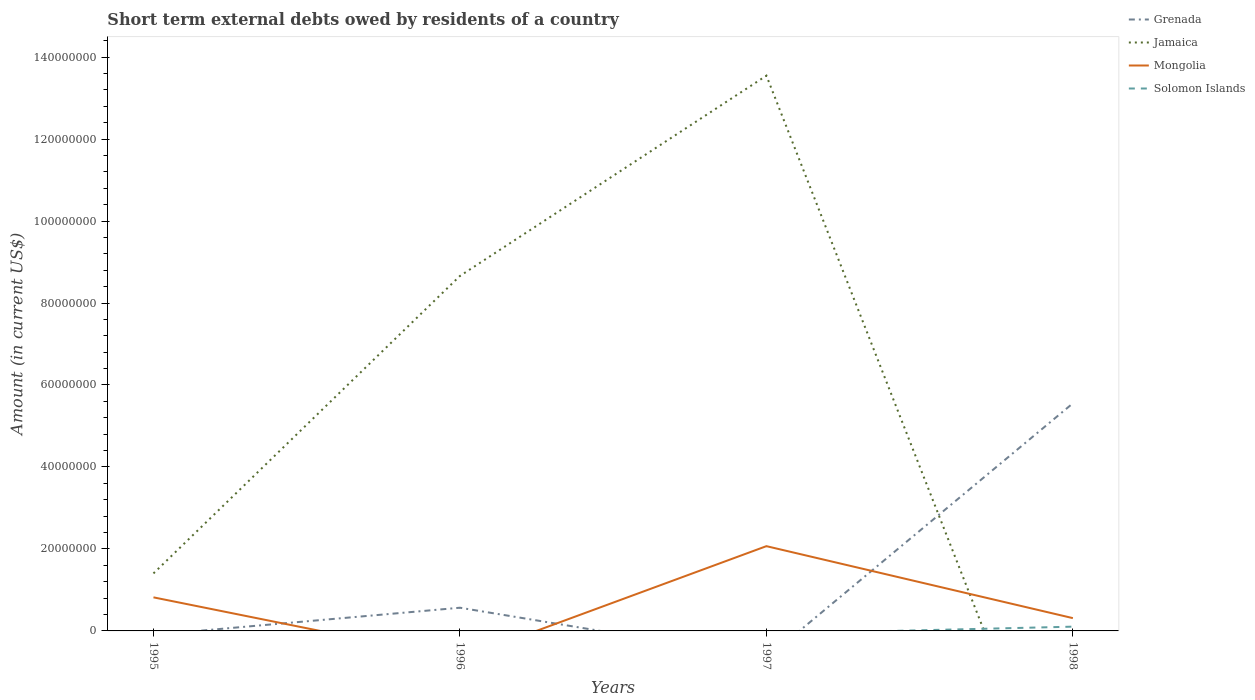Across all years, what is the maximum amount of short-term external debts owed by residents in Grenada?
Offer a very short reply. 0. What is the total amount of short-term external debts owed by residents in Mongolia in the graph?
Offer a terse response. 5.07e+06. What is the difference between the highest and the second highest amount of short-term external debts owed by residents in Grenada?
Your response must be concise. 5.55e+07. What is the difference between the highest and the lowest amount of short-term external debts owed by residents in Mongolia?
Make the answer very short. 2. Does the graph contain grids?
Provide a succinct answer. No. How many legend labels are there?
Keep it short and to the point. 4. What is the title of the graph?
Offer a terse response. Short term external debts owed by residents of a country. Does "Syrian Arab Republic" appear as one of the legend labels in the graph?
Offer a terse response. No. What is the label or title of the Y-axis?
Your answer should be compact. Amount (in current US$). What is the Amount (in current US$) in Jamaica in 1995?
Provide a succinct answer. 1.40e+07. What is the Amount (in current US$) in Mongolia in 1995?
Provide a short and direct response. 8.19e+06. What is the Amount (in current US$) of Grenada in 1996?
Your answer should be compact. 5.66e+06. What is the Amount (in current US$) in Jamaica in 1996?
Provide a succinct answer. 8.66e+07. What is the Amount (in current US$) of Mongolia in 1996?
Your answer should be very brief. 0. What is the Amount (in current US$) of Solomon Islands in 1996?
Give a very brief answer. 0. What is the Amount (in current US$) in Jamaica in 1997?
Give a very brief answer. 1.35e+08. What is the Amount (in current US$) in Mongolia in 1997?
Make the answer very short. 2.07e+07. What is the Amount (in current US$) of Grenada in 1998?
Keep it short and to the point. 5.55e+07. What is the Amount (in current US$) of Mongolia in 1998?
Make the answer very short. 3.12e+06. What is the Amount (in current US$) in Solomon Islands in 1998?
Your response must be concise. 1.04e+06. Across all years, what is the maximum Amount (in current US$) in Grenada?
Offer a terse response. 5.55e+07. Across all years, what is the maximum Amount (in current US$) in Jamaica?
Provide a succinct answer. 1.35e+08. Across all years, what is the maximum Amount (in current US$) of Mongolia?
Provide a succinct answer. 2.07e+07. Across all years, what is the maximum Amount (in current US$) in Solomon Islands?
Offer a terse response. 1.04e+06. Across all years, what is the minimum Amount (in current US$) of Grenada?
Your response must be concise. 0. Across all years, what is the minimum Amount (in current US$) of Jamaica?
Offer a very short reply. 0. What is the total Amount (in current US$) in Grenada in the graph?
Offer a terse response. 6.12e+07. What is the total Amount (in current US$) of Jamaica in the graph?
Provide a short and direct response. 2.36e+08. What is the total Amount (in current US$) of Mongolia in the graph?
Your response must be concise. 3.20e+07. What is the total Amount (in current US$) in Solomon Islands in the graph?
Your response must be concise. 1.04e+06. What is the difference between the Amount (in current US$) of Jamaica in 1995 and that in 1996?
Keep it short and to the point. -7.26e+07. What is the difference between the Amount (in current US$) of Jamaica in 1995 and that in 1997?
Offer a terse response. -1.21e+08. What is the difference between the Amount (in current US$) of Mongolia in 1995 and that in 1997?
Keep it short and to the point. -1.25e+07. What is the difference between the Amount (in current US$) in Mongolia in 1995 and that in 1998?
Offer a terse response. 5.07e+06. What is the difference between the Amount (in current US$) in Jamaica in 1996 and that in 1997?
Offer a very short reply. -4.89e+07. What is the difference between the Amount (in current US$) in Grenada in 1996 and that in 1998?
Make the answer very short. -4.99e+07. What is the difference between the Amount (in current US$) of Mongolia in 1997 and that in 1998?
Offer a terse response. 1.76e+07. What is the difference between the Amount (in current US$) of Jamaica in 1995 and the Amount (in current US$) of Mongolia in 1997?
Keep it short and to the point. -6.65e+06. What is the difference between the Amount (in current US$) in Jamaica in 1995 and the Amount (in current US$) in Mongolia in 1998?
Provide a succinct answer. 1.09e+07. What is the difference between the Amount (in current US$) of Jamaica in 1995 and the Amount (in current US$) of Solomon Islands in 1998?
Offer a very short reply. 1.30e+07. What is the difference between the Amount (in current US$) of Mongolia in 1995 and the Amount (in current US$) of Solomon Islands in 1998?
Make the answer very short. 7.15e+06. What is the difference between the Amount (in current US$) in Grenada in 1996 and the Amount (in current US$) in Jamaica in 1997?
Your response must be concise. -1.30e+08. What is the difference between the Amount (in current US$) in Grenada in 1996 and the Amount (in current US$) in Mongolia in 1997?
Provide a short and direct response. -1.50e+07. What is the difference between the Amount (in current US$) in Jamaica in 1996 and the Amount (in current US$) in Mongolia in 1997?
Keep it short and to the point. 6.59e+07. What is the difference between the Amount (in current US$) in Grenada in 1996 and the Amount (in current US$) in Mongolia in 1998?
Your response must be concise. 2.54e+06. What is the difference between the Amount (in current US$) in Grenada in 1996 and the Amount (in current US$) in Solomon Islands in 1998?
Keep it short and to the point. 4.62e+06. What is the difference between the Amount (in current US$) in Jamaica in 1996 and the Amount (in current US$) in Mongolia in 1998?
Your response must be concise. 8.35e+07. What is the difference between the Amount (in current US$) of Jamaica in 1996 and the Amount (in current US$) of Solomon Islands in 1998?
Provide a short and direct response. 8.56e+07. What is the difference between the Amount (in current US$) in Jamaica in 1997 and the Amount (in current US$) in Mongolia in 1998?
Your response must be concise. 1.32e+08. What is the difference between the Amount (in current US$) of Jamaica in 1997 and the Amount (in current US$) of Solomon Islands in 1998?
Your answer should be very brief. 1.34e+08. What is the difference between the Amount (in current US$) in Mongolia in 1997 and the Amount (in current US$) in Solomon Islands in 1998?
Provide a short and direct response. 1.96e+07. What is the average Amount (in current US$) in Grenada per year?
Give a very brief answer. 1.53e+07. What is the average Amount (in current US$) in Jamaica per year?
Keep it short and to the point. 5.90e+07. What is the average Amount (in current US$) of Mongolia per year?
Offer a very short reply. 8.00e+06. In the year 1995, what is the difference between the Amount (in current US$) of Jamaica and Amount (in current US$) of Mongolia?
Provide a short and direct response. 5.84e+06. In the year 1996, what is the difference between the Amount (in current US$) in Grenada and Amount (in current US$) in Jamaica?
Make the answer very short. -8.09e+07. In the year 1997, what is the difference between the Amount (in current US$) in Jamaica and Amount (in current US$) in Mongolia?
Offer a very short reply. 1.15e+08. In the year 1998, what is the difference between the Amount (in current US$) in Grenada and Amount (in current US$) in Mongolia?
Your answer should be very brief. 5.24e+07. In the year 1998, what is the difference between the Amount (in current US$) of Grenada and Amount (in current US$) of Solomon Islands?
Your response must be concise. 5.45e+07. In the year 1998, what is the difference between the Amount (in current US$) of Mongolia and Amount (in current US$) of Solomon Islands?
Keep it short and to the point. 2.08e+06. What is the ratio of the Amount (in current US$) in Jamaica in 1995 to that in 1996?
Make the answer very short. 0.16. What is the ratio of the Amount (in current US$) in Jamaica in 1995 to that in 1997?
Give a very brief answer. 0.1. What is the ratio of the Amount (in current US$) of Mongolia in 1995 to that in 1997?
Your response must be concise. 0.4. What is the ratio of the Amount (in current US$) in Mongolia in 1995 to that in 1998?
Your answer should be very brief. 2.62. What is the ratio of the Amount (in current US$) in Jamaica in 1996 to that in 1997?
Make the answer very short. 0.64. What is the ratio of the Amount (in current US$) of Grenada in 1996 to that in 1998?
Your answer should be compact. 0.1. What is the ratio of the Amount (in current US$) in Mongolia in 1997 to that in 1998?
Provide a short and direct response. 6.63. What is the difference between the highest and the second highest Amount (in current US$) of Jamaica?
Your answer should be compact. 4.89e+07. What is the difference between the highest and the second highest Amount (in current US$) of Mongolia?
Your response must be concise. 1.25e+07. What is the difference between the highest and the lowest Amount (in current US$) in Grenada?
Provide a succinct answer. 5.55e+07. What is the difference between the highest and the lowest Amount (in current US$) in Jamaica?
Your answer should be compact. 1.35e+08. What is the difference between the highest and the lowest Amount (in current US$) of Mongolia?
Your response must be concise. 2.07e+07. What is the difference between the highest and the lowest Amount (in current US$) in Solomon Islands?
Provide a short and direct response. 1.04e+06. 